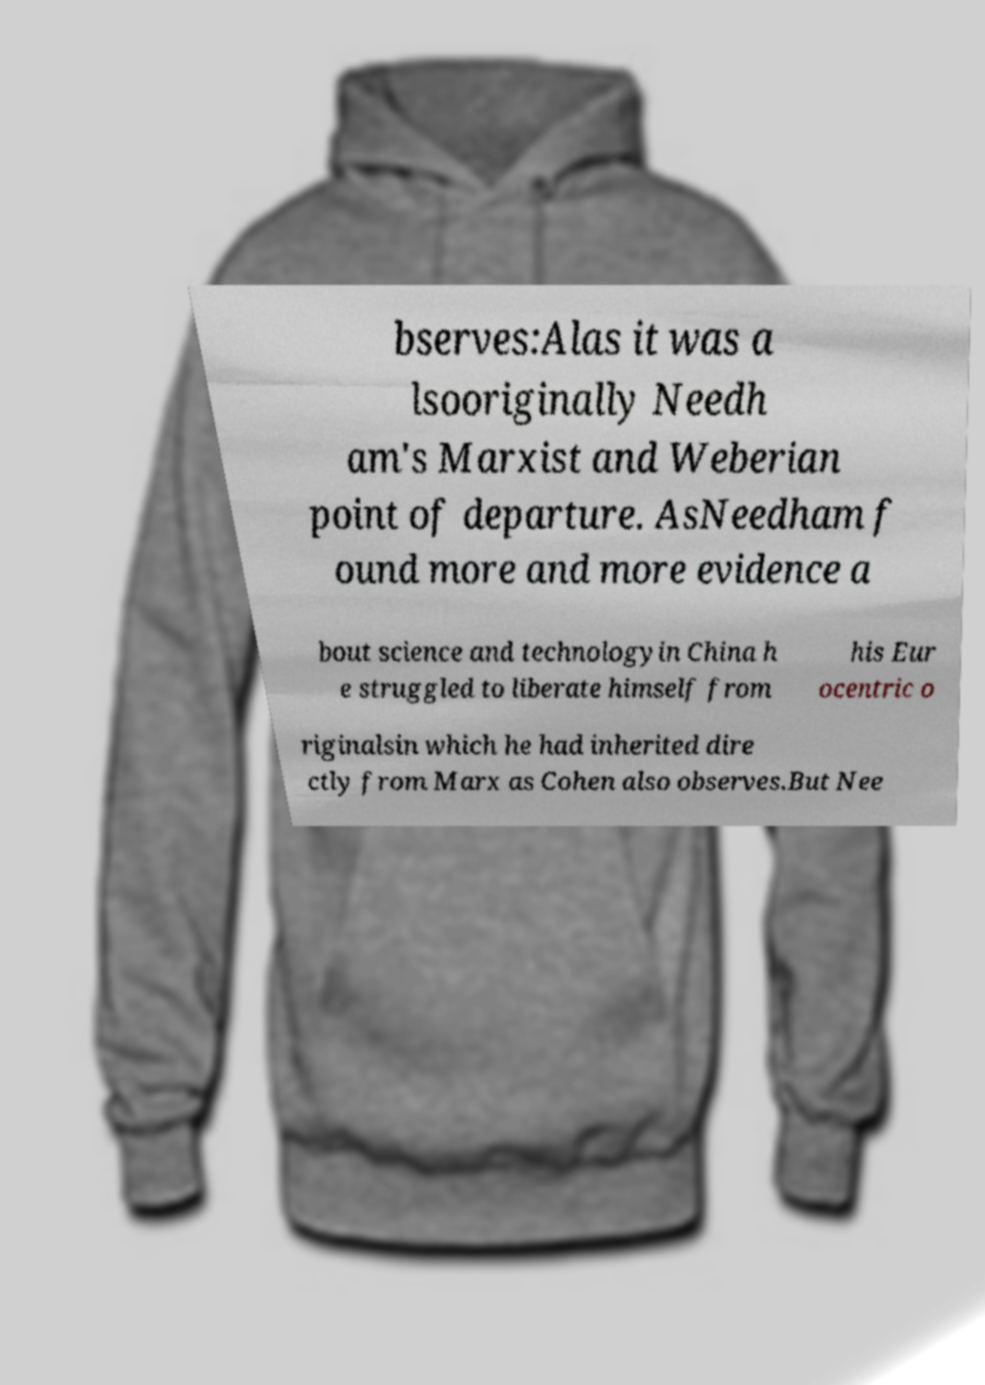Please read and relay the text visible in this image. What does it say? bserves:Alas it was a lsooriginally Needh am's Marxist and Weberian point of departure. AsNeedham f ound more and more evidence a bout science and technologyin China h e struggled to liberate himself from his Eur ocentric o riginalsin which he had inherited dire ctly from Marx as Cohen also observes.But Nee 